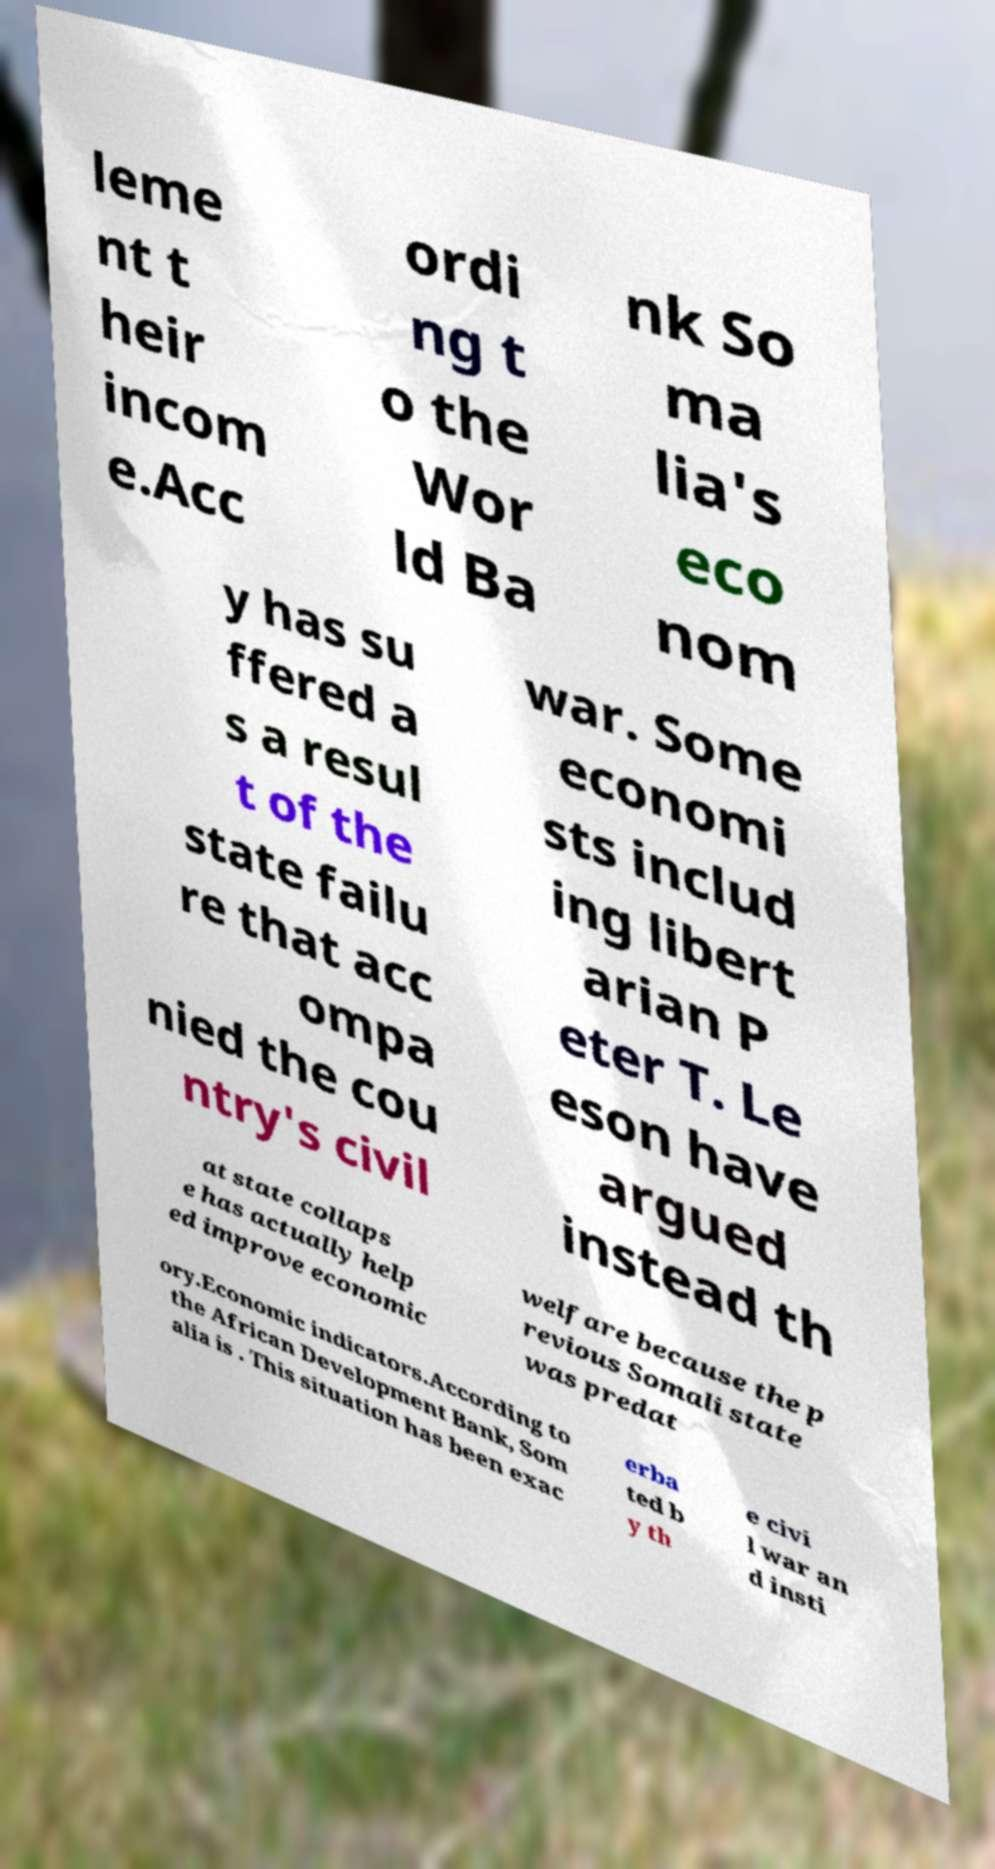Please identify and transcribe the text found in this image. leme nt t heir incom e.Acc ordi ng t o the Wor ld Ba nk So ma lia's eco nom y has su ffered a s a resul t of the state failu re that acc ompa nied the cou ntry's civil war. Some economi sts includ ing libert arian P eter T. Le eson have argued instead th at state collaps e has actually help ed improve economic welfare because the p revious Somali state was predat ory.Economic indicators.According to the African Development Bank, Som alia is . This situation has been exac erba ted b y th e civi l war an d insti 